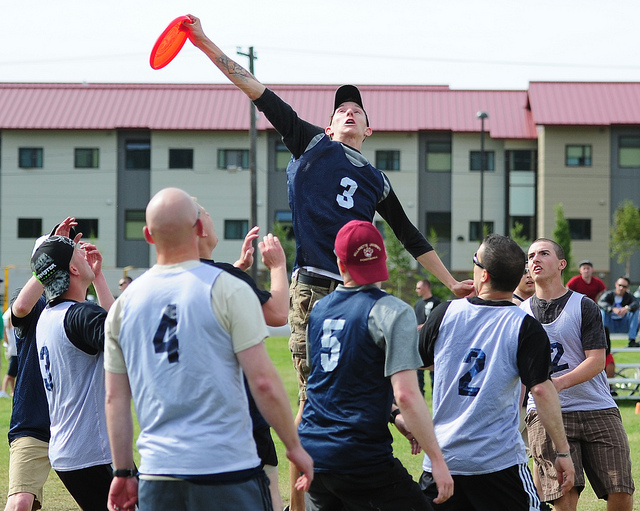Identify the text displayed in this image. 3 4 5 3 2 2 